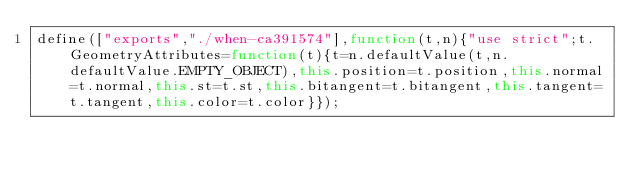<code> <loc_0><loc_0><loc_500><loc_500><_JavaScript_>define(["exports","./when-ca391574"],function(t,n){"use strict";t.GeometryAttributes=function(t){t=n.defaultValue(t,n.defaultValue.EMPTY_OBJECT),this.position=t.position,this.normal=t.normal,this.st=t.st,this.bitangent=t.bitangent,this.tangent=t.tangent,this.color=t.color}});
</code> 